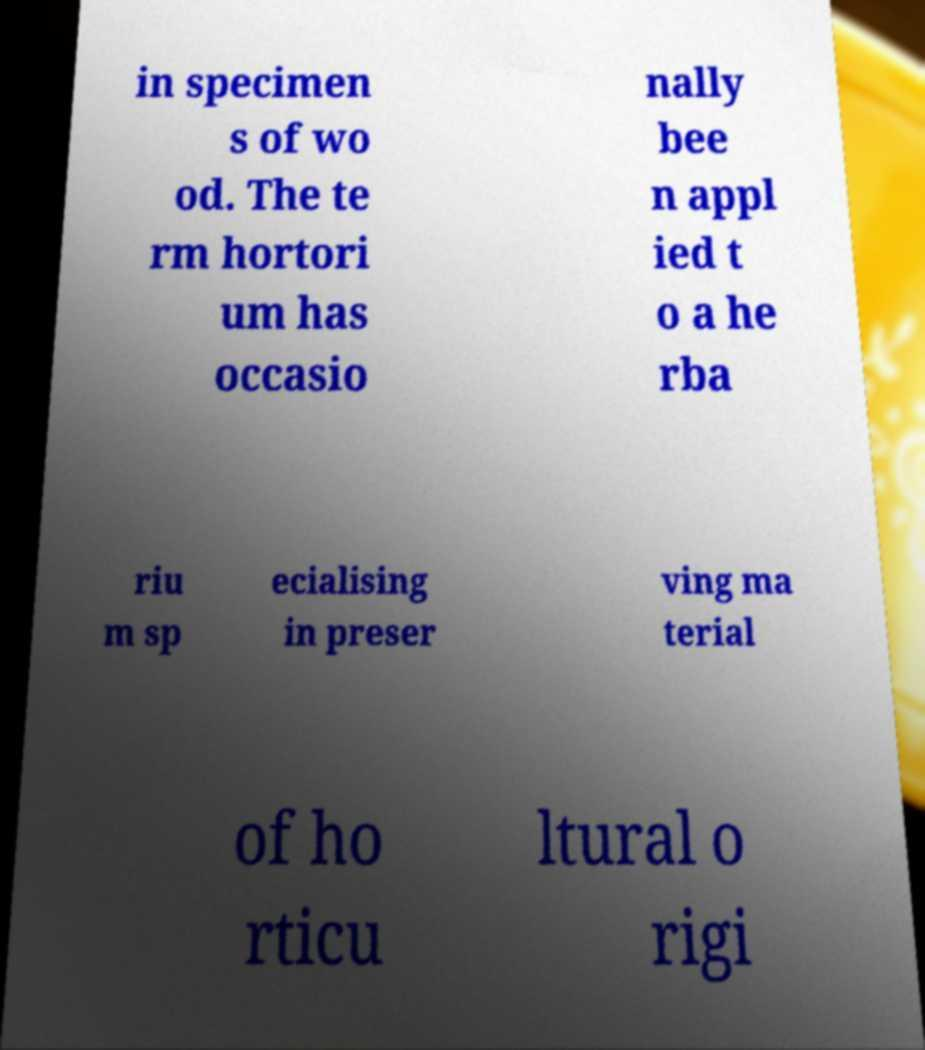Please identify and transcribe the text found in this image. in specimen s of wo od. The te rm hortori um has occasio nally bee n appl ied t o a he rba riu m sp ecialising in preser ving ma terial of ho rticu ltural o rigi 